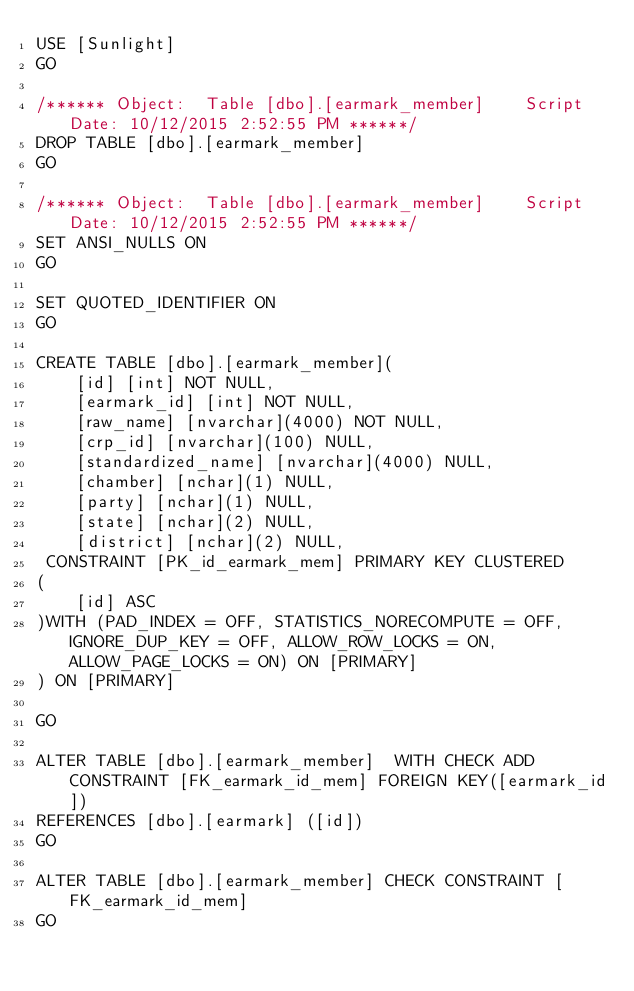<code> <loc_0><loc_0><loc_500><loc_500><_SQL_>USE [Sunlight]
GO

/****** Object:  Table [dbo].[earmark_member]    Script Date: 10/12/2015 2:52:55 PM ******/
DROP TABLE [dbo].[earmark_member]
GO

/****** Object:  Table [dbo].[earmark_member]    Script Date: 10/12/2015 2:52:55 PM ******/
SET ANSI_NULLS ON
GO

SET QUOTED_IDENTIFIER ON
GO

CREATE TABLE [dbo].[earmark_member](
	[id] [int] NOT NULL,
	[earmark_id] [int] NOT NULL,
	[raw_name] [nvarchar](4000) NOT NULL,
	[crp_id] [nvarchar](100) NULL,
	[standardized_name] [nvarchar](4000) NULL,
	[chamber] [nchar](1) NULL,
	[party] [nchar](1) NULL,
	[state] [nchar](2) NULL,
	[district] [nchar](2) NULL,
 CONSTRAINT [PK_id_earmark_mem] PRIMARY KEY CLUSTERED 
(
	[id] ASC
)WITH (PAD_INDEX = OFF, STATISTICS_NORECOMPUTE = OFF, IGNORE_DUP_KEY = OFF, ALLOW_ROW_LOCKS = ON, ALLOW_PAGE_LOCKS = ON) ON [PRIMARY]
) ON [PRIMARY]

GO

ALTER TABLE [dbo].[earmark_member]  WITH CHECK ADD  CONSTRAINT [FK_earmark_id_mem] FOREIGN KEY([earmark_id])
REFERENCES [dbo].[earmark] ([id])
GO

ALTER TABLE [dbo].[earmark_member] CHECK CONSTRAINT [FK_earmark_id_mem]
GO

</code> 